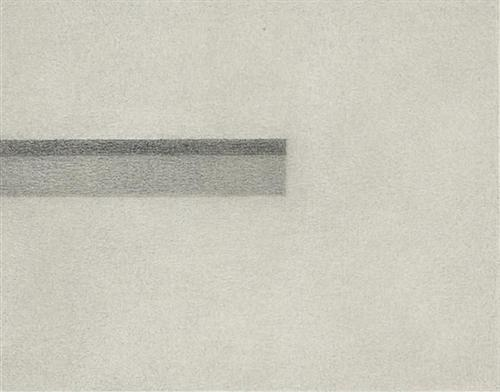What are the key elements in this picture? The photograph showcases a prime example of minimalist art, focusing on simplistic yet profound visual elements. The central feature is a clean, horizontally extended line with a soft gradient transitioning from dark gray to lighter shades, positioned against a stark white backdrop. This contrast not only foregrounds the line but also invites contemplation on the interplay between light and shadow, tranquility and dynamism. The texture of the line, slightly grainy and uneven, adds a tactile dimension, making the piece a subtle exploration of form and the emotional response it may elicit. This artwork might be interpreted as a metaphor for calmness and continuity or, conversely, isolation and division, depending on the viewer’s perspective. 